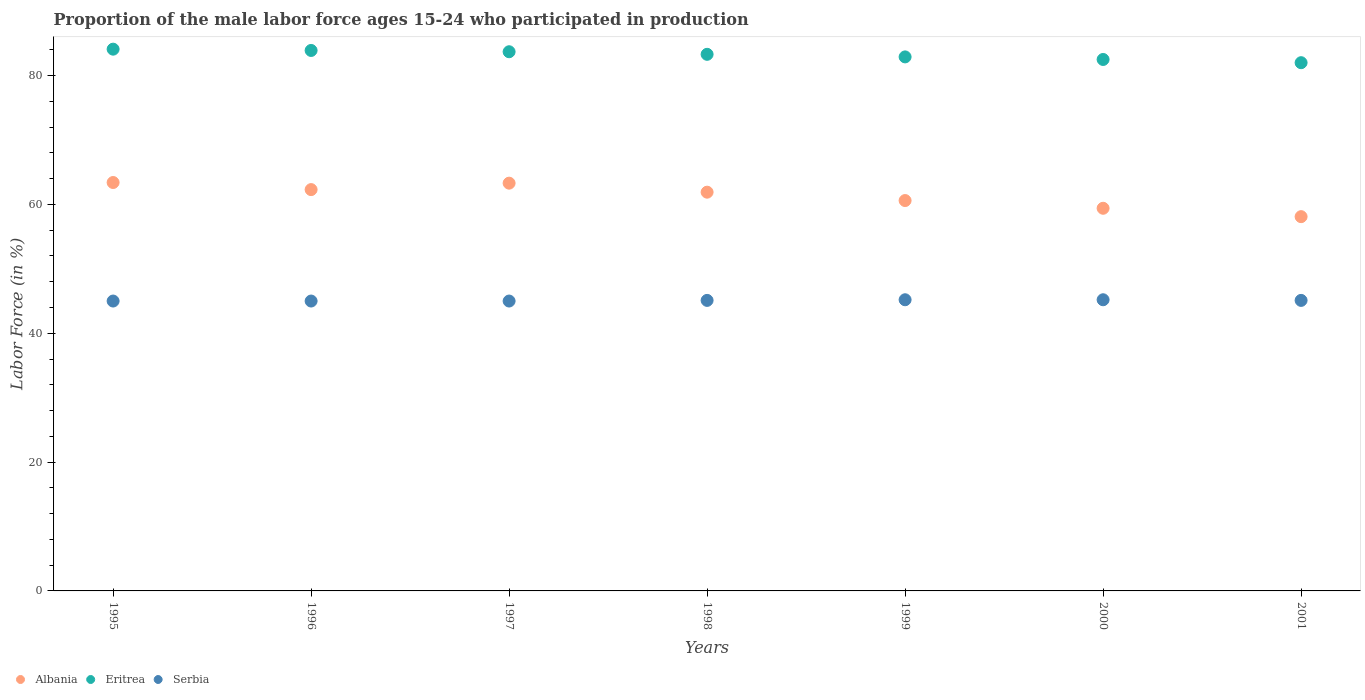How many different coloured dotlines are there?
Offer a terse response. 3. Is the number of dotlines equal to the number of legend labels?
Provide a succinct answer. Yes. What is the proportion of the male labor force who participated in production in Eritrea in 1996?
Offer a very short reply. 83.9. Across all years, what is the maximum proportion of the male labor force who participated in production in Eritrea?
Keep it short and to the point. 84.1. Across all years, what is the minimum proportion of the male labor force who participated in production in Eritrea?
Provide a succinct answer. 82. In which year was the proportion of the male labor force who participated in production in Serbia maximum?
Your answer should be very brief. 1999. In which year was the proportion of the male labor force who participated in production in Albania minimum?
Make the answer very short. 2001. What is the total proportion of the male labor force who participated in production in Albania in the graph?
Keep it short and to the point. 429. What is the difference between the proportion of the male labor force who participated in production in Albania in 1998 and that in 2001?
Provide a succinct answer. 3.8. What is the difference between the proportion of the male labor force who participated in production in Eritrea in 2000 and the proportion of the male labor force who participated in production in Albania in 1996?
Provide a short and direct response. 20.2. What is the average proportion of the male labor force who participated in production in Eritrea per year?
Ensure brevity in your answer.  83.2. In the year 2001, what is the difference between the proportion of the male labor force who participated in production in Eritrea and proportion of the male labor force who participated in production in Serbia?
Provide a succinct answer. 36.9. In how many years, is the proportion of the male labor force who participated in production in Albania greater than 80 %?
Your answer should be very brief. 0. What is the ratio of the proportion of the male labor force who participated in production in Serbia in 1997 to that in 1999?
Your response must be concise. 1. What is the difference between the highest and the second highest proportion of the male labor force who participated in production in Eritrea?
Offer a very short reply. 0.2. What is the difference between the highest and the lowest proportion of the male labor force who participated in production in Eritrea?
Give a very brief answer. 2.1. In how many years, is the proportion of the male labor force who participated in production in Albania greater than the average proportion of the male labor force who participated in production in Albania taken over all years?
Your answer should be very brief. 4. Is the sum of the proportion of the male labor force who participated in production in Serbia in 1996 and 1997 greater than the maximum proportion of the male labor force who participated in production in Albania across all years?
Offer a terse response. Yes. Is the proportion of the male labor force who participated in production in Albania strictly greater than the proportion of the male labor force who participated in production in Serbia over the years?
Your answer should be very brief. Yes. How many dotlines are there?
Make the answer very short. 3. Are the values on the major ticks of Y-axis written in scientific E-notation?
Provide a short and direct response. No. Where does the legend appear in the graph?
Ensure brevity in your answer.  Bottom left. How many legend labels are there?
Your answer should be compact. 3. What is the title of the graph?
Your answer should be very brief. Proportion of the male labor force ages 15-24 who participated in production. Does "Mozambique" appear as one of the legend labels in the graph?
Your answer should be compact. No. What is the Labor Force (in %) in Albania in 1995?
Your answer should be compact. 63.4. What is the Labor Force (in %) of Eritrea in 1995?
Your answer should be very brief. 84.1. What is the Labor Force (in %) of Serbia in 1995?
Ensure brevity in your answer.  45. What is the Labor Force (in %) of Albania in 1996?
Ensure brevity in your answer.  62.3. What is the Labor Force (in %) in Eritrea in 1996?
Your response must be concise. 83.9. What is the Labor Force (in %) of Albania in 1997?
Make the answer very short. 63.3. What is the Labor Force (in %) in Eritrea in 1997?
Provide a short and direct response. 83.7. What is the Labor Force (in %) of Albania in 1998?
Keep it short and to the point. 61.9. What is the Labor Force (in %) in Eritrea in 1998?
Make the answer very short. 83.3. What is the Labor Force (in %) in Serbia in 1998?
Your answer should be very brief. 45.1. What is the Labor Force (in %) in Albania in 1999?
Your response must be concise. 60.6. What is the Labor Force (in %) in Eritrea in 1999?
Your answer should be very brief. 82.9. What is the Labor Force (in %) in Serbia in 1999?
Your answer should be compact. 45.2. What is the Labor Force (in %) of Albania in 2000?
Give a very brief answer. 59.4. What is the Labor Force (in %) in Eritrea in 2000?
Ensure brevity in your answer.  82.5. What is the Labor Force (in %) in Serbia in 2000?
Keep it short and to the point. 45.2. What is the Labor Force (in %) in Albania in 2001?
Offer a terse response. 58.1. What is the Labor Force (in %) of Eritrea in 2001?
Provide a short and direct response. 82. What is the Labor Force (in %) of Serbia in 2001?
Your answer should be compact. 45.1. Across all years, what is the maximum Labor Force (in %) in Albania?
Provide a succinct answer. 63.4. Across all years, what is the maximum Labor Force (in %) of Eritrea?
Your response must be concise. 84.1. Across all years, what is the maximum Labor Force (in %) in Serbia?
Provide a succinct answer. 45.2. Across all years, what is the minimum Labor Force (in %) of Albania?
Ensure brevity in your answer.  58.1. Across all years, what is the minimum Labor Force (in %) in Serbia?
Your response must be concise. 45. What is the total Labor Force (in %) in Albania in the graph?
Your response must be concise. 429. What is the total Labor Force (in %) in Eritrea in the graph?
Give a very brief answer. 582.4. What is the total Labor Force (in %) of Serbia in the graph?
Make the answer very short. 315.6. What is the difference between the Labor Force (in %) in Eritrea in 1995 and that in 1996?
Keep it short and to the point. 0.2. What is the difference between the Labor Force (in %) of Serbia in 1995 and that in 1996?
Offer a terse response. 0. What is the difference between the Labor Force (in %) of Albania in 1995 and that in 1997?
Your answer should be very brief. 0.1. What is the difference between the Labor Force (in %) of Eritrea in 1995 and that in 1997?
Your answer should be very brief. 0.4. What is the difference between the Labor Force (in %) of Serbia in 1995 and that in 1998?
Ensure brevity in your answer.  -0.1. What is the difference between the Labor Force (in %) in Albania in 1995 and that in 1999?
Provide a short and direct response. 2.8. What is the difference between the Labor Force (in %) of Eritrea in 1995 and that in 1999?
Your response must be concise. 1.2. What is the difference between the Labor Force (in %) of Eritrea in 1995 and that in 2000?
Offer a very short reply. 1.6. What is the difference between the Labor Force (in %) of Serbia in 1995 and that in 2000?
Give a very brief answer. -0.2. What is the difference between the Labor Force (in %) in Eritrea in 1995 and that in 2001?
Offer a very short reply. 2.1. What is the difference between the Labor Force (in %) of Serbia in 1995 and that in 2001?
Ensure brevity in your answer.  -0.1. What is the difference between the Labor Force (in %) in Eritrea in 1996 and that in 1997?
Make the answer very short. 0.2. What is the difference between the Labor Force (in %) of Serbia in 1996 and that in 1997?
Ensure brevity in your answer.  0. What is the difference between the Labor Force (in %) in Albania in 1996 and that in 1998?
Ensure brevity in your answer.  0.4. What is the difference between the Labor Force (in %) in Serbia in 1996 and that in 1998?
Keep it short and to the point. -0.1. What is the difference between the Labor Force (in %) of Serbia in 1996 and that in 1999?
Provide a succinct answer. -0.2. What is the difference between the Labor Force (in %) of Eritrea in 1997 and that in 1998?
Your response must be concise. 0.4. What is the difference between the Labor Force (in %) of Albania in 1997 and that in 1999?
Offer a very short reply. 2.7. What is the difference between the Labor Force (in %) of Serbia in 1997 and that in 1999?
Offer a terse response. -0.2. What is the difference between the Labor Force (in %) in Albania in 1997 and that in 2000?
Make the answer very short. 3.9. What is the difference between the Labor Force (in %) in Albania in 1997 and that in 2001?
Provide a short and direct response. 5.2. What is the difference between the Labor Force (in %) in Eritrea in 1997 and that in 2001?
Your answer should be compact. 1.7. What is the difference between the Labor Force (in %) of Eritrea in 1998 and that in 1999?
Your answer should be very brief. 0.4. What is the difference between the Labor Force (in %) in Albania in 1998 and that in 2000?
Your answer should be very brief. 2.5. What is the difference between the Labor Force (in %) of Serbia in 1998 and that in 2000?
Offer a very short reply. -0.1. What is the difference between the Labor Force (in %) in Eritrea in 1998 and that in 2001?
Your answer should be compact. 1.3. What is the difference between the Labor Force (in %) of Serbia in 1998 and that in 2001?
Provide a succinct answer. 0. What is the difference between the Labor Force (in %) in Eritrea in 1999 and that in 2001?
Make the answer very short. 0.9. What is the difference between the Labor Force (in %) of Serbia in 1999 and that in 2001?
Your answer should be very brief. 0.1. What is the difference between the Labor Force (in %) in Albania in 2000 and that in 2001?
Make the answer very short. 1.3. What is the difference between the Labor Force (in %) in Eritrea in 2000 and that in 2001?
Provide a short and direct response. 0.5. What is the difference between the Labor Force (in %) in Albania in 1995 and the Labor Force (in %) in Eritrea in 1996?
Ensure brevity in your answer.  -20.5. What is the difference between the Labor Force (in %) of Albania in 1995 and the Labor Force (in %) of Serbia in 1996?
Ensure brevity in your answer.  18.4. What is the difference between the Labor Force (in %) in Eritrea in 1995 and the Labor Force (in %) in Serbia in 1996?
Keep it short and to the point. 39.1. What is the difference between the Labor Force (in %) of Albania in 1995 and the Labor Force (in %) of Eritrea in 1997?
Make the answer very short. -20.3. What is the difference between the Labor Force (in %) in Albania in 1995 and the Labor Force (in %) in Serbia in 1997?
Provide a succinct answer. 18.4. What is the difference between the Labor Force (in %) in Eritrea in 1995 and the Labor Force (in %) in Serbia in 1997?
Make the answer very short. 39.1. What is the difference between the Labor Force (in %) in Albania in 1995 and the Labor Force (in %) in Eritrea in 1998?
Your answer should be very brief. -19.9. What is the difference between the Labor Force (in %) in Albania in 1995 and the Labor Force (in %) in Eritrea in 1999?
Your answer should be very brief. -19.5. What is the difference between the Labor Force (in %) in Eritrea in 1995 and the Labor Force (in %) in Serbia in 1999?
Your answer should be compact. 38.9. What is the difference between the Labor Force (in %) in Albania in 1995 and the Labor Force (in %) in Eritrea in 2000?
Give a very brief answer. -19.1. What is the difference between the Labor Force (in %) in Albania in 1995 and the Labor Force (in %) in Serbia in 2000?
Make the answer very short. 18.2. What is the difference between the Labor Force (in %) in Eritrea in 1995 and the Labor Force (in %) in Serbia in 2000?
Your answer should be compact. 38.9. What is the difference between the Labor Force (in %) in Albania in 1995 and the Labor Force (in %) in Eritrea in 2001?
Ensure brevity in your answer.  -18.6. What is the difference between the Labor Force (in %) in Albania in 1995 and the Labor Force (in %) in Serbia in 2001?
Provide a succinct answer. 18.3. What is the difference between the Labor Force (in %) of Albania in 1996 and the Labor Force (in %) of Eritrea in 1997?
Give a very brief answer. -21.4. What is the difference between the Labor Force (in %) in Eritrea in 1996 and the Labor Force (in %) in Serbia in 1997?
Your response must be concise. 38.9. What is the difference between the Labor Force (in %) in Eritrea in 1996 and the Labor Force (in %) in Serbia in 1998?
Your response must be concise. 38.8. What is the difference between the Labor Force (in %) in Albania in 1996 and the Labor Force (in %) in Eritrea in 1999?
Provide a succinct answer. -20.6. What is the difference between the Labor Force (in %) in Eritrea in 1996 and the Labor Force (in %) in Serbia in 1999?
Provide a succinct answer. 38.7. What is the difference between the Labor Force (in %) of Albania in 1996 and the Labor Force (in %) of Eritrea in 2000?
Your response must be concise. -20.2. What is the difference between the Labor Force (in %) of Albania in 1996 and the Labor Force (in %) of Serbia in 2000?
Your response must be concise. 17.1. What is the difference between the Labor Force (in %) in Eritrea in 1996 and the Labor Force (in %) in Serbia in 2000?
Your response must be concise. 38.7. What is the difference between the Labor Force (in %) in Albania in 1996 and the Labor Force (in %) in Eritrea in 2001?
Your answer should be very brief. -19.7. What is the difference between the Labor Force (in %) of Eritrea in 1996 and the Labor Force (in %) of Serbia in 2001?
Provide a short and direct response. 38.8. What is the difference between the Labor Force (in %) of Albania in 1997 and the Labor Force (in %) of Eritrea in 1998?
Offer a very short reply. -20. What is the difference between the Labor Force (in %) in Albania in 1997 and the Labor Force (in %) in Serbia in 1998?
Your response must be concise. 18.2. What is the difference between the Labor Force (in %) of Eritrea in 1997 and the Labor Force (in %) of Serbia in 1998?
Provide a short and direct response. 38.6. What is the difference between the Labor Force (in %) of Albania in 1997 and the Labor Force (in %) of Eritrea in 1999?
Give a very brief answer. -19.6. What is the difference between the Labor Force (in %) in Eritrea in 1997 and the Labor Force (in %) in Serbia in 1999?
Ensure brevity in your answer.  38.5. What is the difference between the Labor Force (in %) of Albania in 1997 and the Labor Force (in %) of Eritrea in 2000?
Provide a succinct answer. -19.2. What is the difference between the Labor Force (in %) of Albania in 1997 and the Labor Force (in %) of Serbia in 2000?
Offer a very short reply. 18.1. What is the difference between the Labor Force (in %) of Eritrea in 1997 and the Labor Force (in %) of Serbia in 2000?
Offer a very short reply. 38.5. What is the difference between the Labor Force (in %) of Albania in 1997 and the Labor Force (in %) of Eritrea in 2001?
Ensure brevity in your answer.  -18.7. What is the difference between the Labor Force (in %) of Eritrea in 1997 and the Labor Force (in %) of Serbia in 2001?
Your response must be concise. 38.6. What is the difference between the Labor Force (in %) of Eritrea in 1998 and the Labor Force (in %) of Serbia in 1999?
Give a very brief answer. 38.1. What is the difference between the Labor Force (in %) of Albania in 1998 and the Labor Force (in %) of Eritrea in 2000?
Your answer should be compact. -20.6. What is the difference between the Labor Force (in %) of Albania in 1998 and the Labor Force (in %) of Serbia in 2000?
Your response must be concise. 16.7. What is the difference between the Labor Force (in %) in Eritrea in 1998 and the Labor Force (in %) in Serbia in 2000?
Offer a terse response. 38.1. What is the difference between the Labor Force (in %) in Albania in 1998 and the Labor Force (in %) in Eritrea in 2001?
Make the answer very short. -20.1. What is the difference between the Labor Force (in %) of Albania in 1998 and the Labor Force (in %) of Serbia in 2001?
Give a very brief answer. 16.8. What is the difference between the Labor Force (in %) of Eritrea in 1998 and the Labor Force (in %) of Serbia in 2001?
Your answer should be compact. 38.2. What is the difference between the Labor Force (in %) of Albania in 1999 and the Labor Force (in %) of Eritrea in 2000?
Ensure brevity in your answer.  -21.9. What is the difference between the Labor Force (in %) in Albania in 1999 and the Labor Force (in %) in Serbia in 2000?
Your response must be concise. 15.4. What is the difference between the Labor Force (in %) in Eritrea in 1999 and the Labor Force (in %) in Serbia in 2000?
Keep it short and to the point. 37.7. What is the difference between the Labor Force (in %) in Albania in 1999 and the Labor Force (in %) in Eritrea in 2001?
Offer a very short reply. -21.4. What is the difference between the Labor Force (in %) in Eritrea in 1999 and the Labor Force (in %) in Serbia in 2001?
Your response must be concise. 37.8. What is the difference between the Labor Force (in %) of Albania in 2000 and the Labor Force (in %) of Eritrea in 2001?
Your answer should be very brief. -22.6. What is the difference between the Labor Force (in %) of Eritrea in 2000 and the Labor Force (in %) of Serbia in 2001?
Provide a succinct answer. 37.4. What is the average Labor Force (in %) in Albania per year?
Your answer should be compact. 61.29. What is the average Labor Force (in %) of Eritrea per year?
Provide a short and direct response. 83.2. What is the average Labor Force (in %) of Serbia per year?
Give a very brief answer. 45.09. In the year 1995, what is the difference between the Labor Force (in %) in Albania and Labor Force (in %) in Eritrea?
Offer a very short reply. -20.7. In the year 1995, what is the difference between the Labor Force (in %) in Albania and Labor Force (in %) in Serbia?
Keep it short and to the point. 18.4. In the year 1995, what is the difference between the Labor Force (in %) in Eritrea and Labor Force (in %) in Serbia?
Your answer should be very brief. 39.1. In the year 1996, what is the difference between the Labor Force (in %) in Albania and Labor Force (in %) in Eritrea?
Offer a terse response. -21.6. In the year 1996, what is the difference between the Labor Force (in %) of Eritrea and Labor Force (in %) of Serbia?
Your answer should be compact. 38.9. In the year 1997, what is the difference between the Labor Force (in %) of Albania and Labor Force (in %) of Eritrea?
Your answer should be compact. -20.4. In the year 1997, what is the difference between the Labor Force (in %) in Albania and Labor Force (in %) in Serbia?
Provide a short and direct response. 18.3. In the year 1997, what is the difference between the Labor Force (in %) of Eritrea and Labor Force (in %) of Serbia?
Keep it short and to the point. 38.7. In the year 1998, what is the difference between the Labor Force (in %) in Albania and Labor Force (in %) in Eritrea?
Provide a short and direct response. -21.4. In the year 1998, what is the difference between the Labor Force (in %) of Eritrea and Labor Force (in %) of Serbia?
Provide a succinct answer. 38.2. In the year 1999, what is the difference between the Labor Force (in %) of Albania and Labor Force (in %) of Eritrea?
Ensure brevity in your answer.  -22.3. In the year 1999, what is the difference between the Labor Force (in %) in Albania and Labor Force (in %) in Serbia?
Provide a short and direct response. 15.4. In the year 1999, what is the difference between the Labor Force (in %) of Eritrea and Labor Force (in %) of Serbia?
Provide a short and direct response. 37.7. In the year 2000, what is the difference between the Labor Force (in %) of Albania and Labor Force (in %) of Eritrea?
Keep it short and to the point. -23.1. In the year 2000, what is the difference between the Labor Force (in %) in Albania and Labor Force (in %) in Serbia?
Your response must be concise. 14.2. In the year 2000, what is the difference between the Labor Force (in %) of Eritrea and Labor Force (in %) of Serbia?
Ensure brevity in your answer.  37.3. In the year 2001, what is the difference between the Labor Force (in %) in Albania and Labor Force (in %) in Eritrea?
Provide a succinct answer. -23.9. In the year 2001, what is the difference between the Labor Force (in %) in Eritrea and Labor Force (in %) in Serbia?
Your answer should be very brief. 36.9. What is the ratio of the Labor Force (in %) in Albania in 1995 to that in 1996?
Give a very brief answer. 1.02. What is the ratio of the Labor Force (in %) of Albania in 1995 to that in 1998?
Offer a very short reply. 1.02. What is the ratio of the Labor Force (in %) in Eritrea in 1995 to that in 1998?
Provide a short and direct response. 1.01. What is the ratio of the Labor Force (in %) in Serbia in 1995 to that in 1998?
Your response must be concise. 1. What is the ratio of the Labor Force (in %) of Albania in 1995 to that in 1999?
Provide a succinct answer. 1.05. What is the ratio of the Labor Force (in %) of Eritrea in 1995 to that in 1999?
Give a very brief answer. 1.01. What is the ratio of the Labor Force (in %) of Albania in 1995 to that in 2000?
Give a very brief answer. 1.07. What is the ratio of the Labor Force (in %) in Eritrea in 1995 to that in 2000?
Keep it short and to the point. 1.02. What is the ratio of the Labor Force (in %) in Albania in 1995 to that in 2001?
Ensure brevity in your answer.  1.09. What is the ratio of the Labor Force (in %) of Eritrea in 1995 to that in 2001?
Your answer should be compact. 1.03. What is the ratio of the Labor Force (in %) in Serbia in 1995 to that in 2001?
Ensure brevity in your answer.  1. What is the ratio of the Labor Force (in %) of Albania in 1996 to that in 1997?
Ensure brevity in your answer.  0.98. What is the ratio of the Labor Force (in %) in Albania in 1996 to that in 1998?
Provide a succinct answer. 1.01. What is the ratio of the Labor Force (in %) in Eritrea in 1996 to that in 1998?
Give a very brief answer. 1.01. What is the ratio of the Labor Force (in %) of Albania in 1996 to that in 1999?
Your answer should be very brief. 1.03. What is the ratio of the Labor Force (in %) of Eritrea in 1996 to that in 1999?
Make the answer very short. 1.01. What is the ratio of the Labor Force (in %) of Serbia in 1996 to that in 1999?
Your response must be concise. 1. What is the ratio of the Labor Force (in %) in Albania in 1996 to that in 2000?
Offer a very short reply. 1.05. What is the ratio of the Labor Force (in %) of Eritrea in 1996 to that in 2000?
Provide a short and direct response. 1.02. What is the ratio of the Labor Force (in %) of Serbia in 1996 to that in 2000?
Make the answer very short. 1. What is the ratio of the Labor Force (in %) in Albania in 1996 to that in 2001?
Your answer should be very brief. 1.07. What is the ratio of the Labor Force (in %) in Eritrea in 1996 to that in 2001?
Provide a short and direct response. 1.02. What is the ratio of the Labor Force (in %) of Albania in 1997 to that in 1998?
Provide a succinct answer. 1.02. What is the ratio of the Labor Force (in %) of Eritrea in 1997 to that in 1998?
Make the answer very short. 1. What is the ratio of the Labor Force (in %) in Serbia in 1997 to that in 1998?
Your answer should be compact. 1. What is the ratio of the Labor Force (in %) in Albania in 1997 to that in 1999?
Your answer should be compact. 1.04. What is the ratio of the Labor Force (in %) of Eritrea in 1997 to that in 1999?
Provide a short and direct response. 1.01. What is the ratio of the Labor Force (in %) in Serbia in 1997 to that in 1999?
Offer a terse response. 1. What is the ratio of the Labor Force (in %) of Albania in 1997 to that in 2000?
Ensure brevity in your answer.  1.07. What is the ratio of the Labor Force (in %) in Eritrea in 1997 to that in 2000?
Provide a short and direct response. 1.01. What is the ratio of the Labor Force (in %) in Albania in 1997 to that in 2001?
Give a very brief answer. 1.09. What is the ratio of the Labor Force (in %) of Eritrea in 1997 to that in 2001?
Provide a short and direct response. 1.02. What is the ratio of the Labor Force (in %) in Albania in 1998 to that in 1999?
Your response must be concise. 1.02. What is the ratio of the Labor Force (in %) in Eritrea in 1998 to that in 1999?
Give a very brief answer. 1. What is the ratio of the Labor Force (in %) of Albania in 1998 to that in 2000?
Make the answer very short. 1.04. What is the ratio of the Labor Force (in %) in Eritrea in 1998 to that in 2000?
Ensure brevity in your answer.  1.01. What is the ratio of the Labor Force (in %) in Serbia in 1998 to that in 2000?
Your response must be concise. 1. What is the ratio of the Labor Force (in %) in Albania in 1998 to that in 2001?
Ensure brevity in your answer.  1.07. What is the ratio of the Labor Force (in %) of Eritrea in 1998 to that in 2001?
Ensure brevity in your answer.  1.02. What is the ratio of the Labor Force (in %) of Serbia in 1998 to that in 2001?
Give a very brief answer. 1. What is the ratio of the Labor Force (in %) of Albania in 1999 to that in 2000?
Offer a very short reply. 1.02. What is the ratio of the Labor Force (in %) of Eritrea in 1999 to that in 2000?
Your response must be concise. 1. What is the ratio of the Labor Force (in %) of Albania in 1999 to that in 2001?
Ensure brevity in your answer.  1.04. What is the ratio of the Labor Force (in %) of Eritrea in 1999 to that in 2001?
Keep it short and to the point. 1.01. What is the ratio of the Labor Force (in %) in Albania in 2000 to that in 2001?
Offer a very short reply. 1.02. What is the difference between the highest and the second highest Labor Force (in %) in Albania?
Give a very brief answer. 0.1. What is the difference between the highest and the second highest Labor Force (in %) of Serbia?
Your answer should be very brief. 0. What is the difference between the highest and the lowest Labor Force (in %) in Eritrea?
Provide a succinct answer. 2.1. 